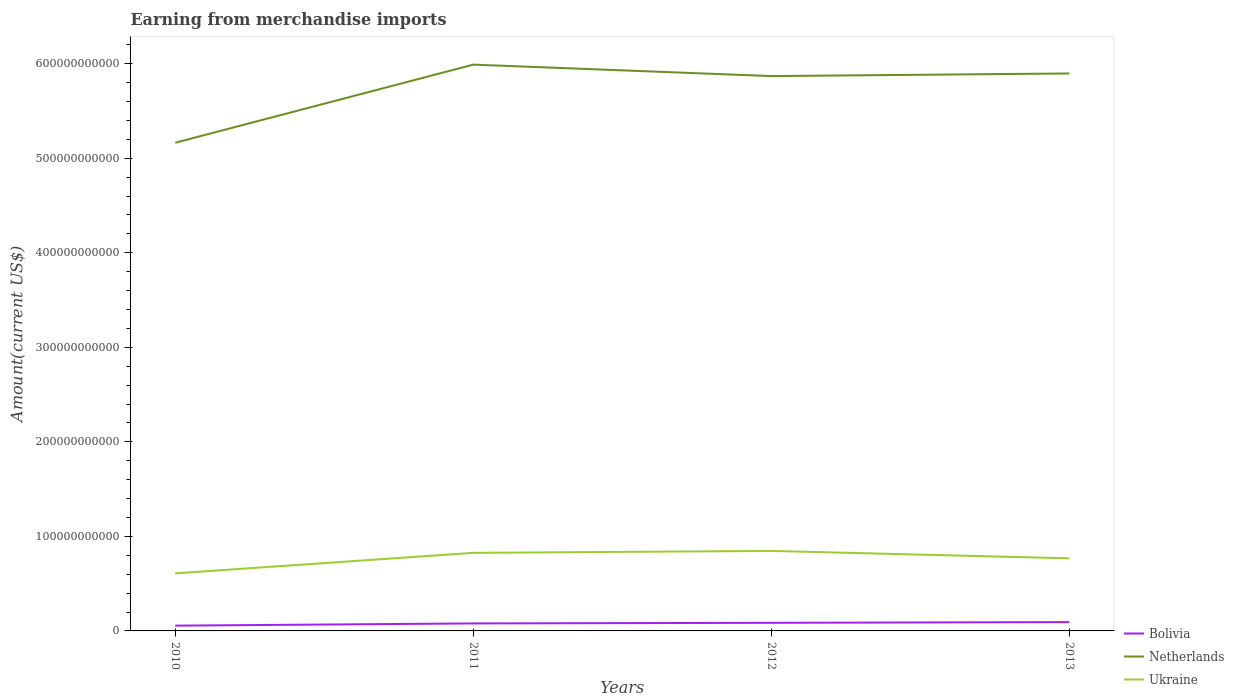Across all years, what is the maximum amount earned from merchandise imports in Ukraine?
Your response must be concise. 6.09e+1. In which year was the amount earned from merchandise imports in Ukraine maximum?
Provide a short and direct response. 2010. What is the total amount earned from merchandise imports in Bolivia in the graph?
Give a very brief answer. -2.34e+09. What is the difference between the highest and the second highest amount earned from merchandise imports in Bolivia?
Offer a very short reply. 3.75e+09. What is the difference between the highest and the lowest amount earned from merchandise imports in Bolivia?
Offer a very short reply. 3. How many lines are there?
Your response must be concise. 3. How many years are there in the graph?
Your answer should be compact. 4. What is the difference between two consecutive major ticks on the Y-axis?
Your answer should be compact. 1.00e+11. How are the legend labels stacked?
Make the answer very short. Vertical. What is the title of the graph?
Make the answer very short. Earning from merchandise imports. What is the label or title of the X-axis?
Provide a succinct answer. Years. What is the label or title of the Y-axis?
Offer a terse response. Amount(current US$). What is the Amount(current US$) in Bolivia in 2010?
Give a very brief answer. 5.59e+09. What is the Amount(current US$) in Netherlands in 2010?
Ensure brevity in your answer.  5.16e+11. What is the Amount(current US$) in Ukraine in 2010?
Your answer should be compact. 6.09e+1. What is the Amount(current US$) of Bolivia in 2011?
Keep it short and to the point. 7.93e+09. What is the Amount(current US$) of Netherlands in 2011?
Keep it short and to the point. 5.99e+11. What is the Amount(current US$) in Ukraine in 2011?
Your answer should be very brief. 8.26e+1. What is the Amount(current US$) of Bolivia in 2012?
Keep it short and to the point. 8.58e+09. What is the Amount(current US$) in Netherlands in 2012?
Ensure brevity in your answer.  5.87e+11. What is the Amount(current US$) in Ukraine in 2012?
Provide a succinct answer. 8.46e+1. What is the Amount(current US$) of Bolivia in 2013?
Make the answer very short. 9.34e+09. What is the Amount(current US$) in Netherlands in 2013?
Your answer should be very brief. 5.90e+11. What is the Amount(current US$) of Ukraine in 2013?
Make the answer very short. 7.68e+1. Across all years, what is the maximum Amount(current US$) of Bolivia?
Give a very brief answer. 9.34e+09. Across all years, what is the maximum Amount(current US$) of Netherlands?
Offer a very short reply. 5.99e+11. Across all years, what is the maximum Amount(current US$) of Ukraine?
Keep it short and to the point. 8.46e+1. Across all years, what is the minimum Amount(current US$) in Bolivia?
Offer a very short reply. 5.59e+09. Across all years, what is the minimum Amount(current US$) of Netherlands?
Offer a terse response. 5.16e+11. Across all years, what is the minimum Amount(current US$) of Ukraine?
Ensure brevity in your answer.  6.09e+1. What is the total Amount(current US$) of Bolivia in the graph?
Offer a very short reply. 3.14e+1. What is the total Amount(current US$) in Netherlands in the graph?
Your response must be concise. 2.29e+12. What is the total Amount(current US$) in Ukraine in the graph?
Ensure brevity in your answer.  3.05e+11. What is the difference between the Amount(current US$) in Bolivia in 2010 and that in 2011?
Provide a succinct answer. -2.34e+09. What is the difference between the Amount(current US$) of Netherlands in 2010 and that in 2011?
Provide a succinct answer. -8.26e+1. What is the difference between the Amount(current US$) of Ukraine in 2010 and that in 2011?
Provide a succinct answer. -2.17e+1. What is the difference between the Amount(current US$) of Bolivia in 2010 and that in 2012?
Offer a very short reply. -2.99e+09. What is the difference between the Amount(current US$) of Netherlands in 2010 and that in 2012?
Your answer should be very brief. -7.05e+1. What is the difference between the Amount(current US$) of Ukraine in 2010 and that in 2012?
Offer a very short reply. -2.37e+1. What is the difference between the Amount(current US$) in Bolivia in 2010 and that in 2013?
Your answer should be very brief. -3.75e+09. What is the difference between the Amount(current US$) of Netherlands in 2010 and that in 2013?
Make the answer very short. -7.33e+1. What is the difference between the Amount(current US$) of Ukraine in 2010 and that in 2013?
Offer a very short reply. -1.59e+1. What is the difference between the Amount(current US$) in Bolivia in 2011 and that in 2012?
Ensure brevity in your answer.  -6.51e+08. What is the difference between the Amount(current US$) of Netherlands in 2011 and that in 2012?
Your answer should be very brief. 1.21e+1. What is the difference between the Amount(current US$) in Ukraine in 2011 and that in 2012?
Offer a terse response. -2.04e+09. What is the difference between the Amount(current US$) of Bolivia in 2011 and that in 2013?
Your answer should be compact. -1.41e+09. What is the difference between the Amount(current US$) of Netherlands in 2011 and that in 2013?
Ensure brevity in your answer.  9.34e+09. What is the difference between the Amount(current US$) in Ukraine in 2011 and that in 2013?
Offer a terse response. 5.81e+09. What is the difference between the Amount(current US$) of Bolivia in 2012 and that in 2013?
Your answer should be very brief. -7.59e+08. What is the difference between the Amount(current US$) of Netherlands in 2012 and that in 2013?
Your answer should be very brief. -2.77e+09. What is the difference between the Amount(current US$) of Ukraine in 2012 and that in 2013?
Your answer should be very brief. 7.85e+09. What is the difference between the Amount(current US$) of Bolivia in 2010 and the Amount(current US$) of Netherlands in 2011?
Your answer should be compact. -5.93e+11. What is the difference between the Amount(current US$) of Bolivia in 2010 and the Amount(current US$) of Ukraine in 2011?
Give a very brief answer. -7.70e+1. What is the difference between the Amount(current US$) of Netherlands in 2010 and the Amount(current US$) of Ukraine in 2011?
Ensure brevity in your answer.  4.34e+11. What is the difference between the Amount(current US$) in Bolivia in 2010 and the Amount(current US$) in Netherlands in 2012?
Offer a very short reply. -5.81e+11. What is the difference between the Amount(current US$) in Bolivia in 2010 and the Amount(current US$) in Ukraine in 2012?
Your answer should be very brief. -7.90e+1. What is the difference between the Amount(current US$) in Netherlands in 2010 and the Amount(current US$) in Ukraine in 2012?
Provide a short and direct response. 4.32e+11. What is the difference between the Amount(current US$) of Bolivia in 2010 and the Amount(current US$) of Netherlands in 2013?
Make the answer very short. -5.84e+11. What is the difference between the Amount(current US$) of Bolivia in 2010 and the Amount(current US$) of Ukraine in 2013?
Offer a very short reply. -7.12e+1. What is the difference between the Amount(current US$) of Netherlands in 2010 and the Amount(current US$) of Ukraine in 2013?
Make the answer very short. 4.40e+11. What is the difference between the Amount(current US$) of Bolivia in 2011 and the Amount(current US$) of Netherlands in 2012?
Keep it short and to the point. -5.79e+11. What is the difference between the Amount(current US$) in Bolivia in 2011 and the Amount(current US$) in Ukraine in 2012?
Your answer should be compact. -7.67e+1. What is the difference between the Amount(current US$) of Netherlands in 2011 and the Amount(current US$) of Ukraine in 2012?
Offer a very short reply. 5.14e+11. What is the difference between the Amount(current US$) in Bolivia in 2011 and the Amount(current US$) in Netherlands in 2013?
Offer a terse response. -5.82e+11. What is the difference between the Amount(current US$) of Bolivia in 2011 and the Amount(current US$) of Ukraine in 2013?
Give a very brief answer. -6.89e+1. What is the difference between the Amount(current US$) of Netherlands in 2011 and the Amount(current US$) of Ukraine in 2013?
Offer a terse response. 5.22e+11. What is the difference between the Amount(current US$) of Bolivia in 2012 and the Amount(current US$) of Netherlands in 2013?
Give a very brief answer. -5.81e+11. What is the difference between the Amount(current US$) of Bolivia in 2012 and the Amount(current US$) of Ukraine in 2013?
Offer a very short reply. -6.82e+1. What is the difference between the Amount(current US$) in Netherlands in 2012 and the Amount(current US$) in Ukraine in 2013?
Keep it short and to the point. 5.10e+11. What is the average Amount(current US$) in Bolivia per year?
Ensure brevity in your answer.  7.86e+09. What is the average Amount(current US$) of Netherlands per year?
Ensure brevity in your answer.  5.73e+11. What is the average Amount(current US$) in Ukraine per year?
Ensure brevity in your answer.  7.62e+1. In the year 2010, what is the difference between the Amount(current US$) in Bolivia and Amount(current US$) in Netherlands?
Your answer should be very brief. -5.11e+11. In the year 2010, what is the difference between the Amount(current US$) in Bolivia and Amount(current US$) in Ukraine?
Keep it short and to the point. -5.53e+1. In the year 2010, what is the difference between the Amount(current US$) of Netherlands and Amount(current US$) of Ukraine?
Ensure brevity in your answer.  4.55e+11. In the year 2011, what is the difference between the Amount(current US$) of Bolivia and Amount(current US$) of Netherlands?
Keep it short and to the point. -5.91e+11. In the year 2011, what is the difference between the Amount(current US$) of Bolivia and Amount(current US$) of Ukraine?
Offer a terse response. -7.47e+1. In the year 2011, what is the difference between the Amount(current US$) of Netherlands and Amount(current US$) of Ukraine?
Give a very brief answer. 5.16e+11. In the year 2012, what is the difference between the Amount(current US$) of Bolivia and Amount(current US$) of Netherlands?
Ensure brevity in your answer.  -5.78e+11. In the year 2012, what is the difference between the Amount(current US$) in Bolivia and Amount(current US$) in Ukraine?
Your answer should be compact. -7.61e+1. In the year 2012, what is the difference between the Amount(current US$) of Netherlands and Amount(current US$) of Ukraine?
Offer a terse response. 5.02e+11. In the year 2013, what is the difference between the Amount(current US$) in Bolivia and Amount(current US$) in Netherlands?
Your answer should be very brief. -5.80e+11. In the year 2013, what is the difference between the Amount(current US$) of Bolivia and Amount(current US$) of Ukraine?
Provide a succinct answer. -6.74e+1. In the year 2013, what is the difference between the Amount(current US$) in Netherlands and Amount(current US$) in Ukraine?
Keep it short and to the point. 5.13e+11. What is the ratio of the Amount(current US$) in Bolivia in 2010 to that in 2011?
Ensure brevity in your answer.  0.71. What is the ratio of the Amount(current US$) of Netherlands in 2010 to that in 2011?
Give a very brief answer. 0.86. What is the ratio of the Amount(current US$) of Ukraine in 2010 to that in 2011?
Offer a very short reply. 0.74. What is the ratio of the Amount(current US$) of Bolivia in 2010 to that in 2012?
Your answer should be compact. 0.65. What is the ratio of the Amount(current US$) of Netherlands in 2010 to that in 2012?
Your response must be concise. 0.88. What is the ratio of the Amount(current US$) of Ukraine in 2010 to that in 2012?
Provide a succinct answer. 0.72. What is the ratio of the Amount(current US$) of Bolivia in 2010 to that in 2013?
Your answer should be very brief. 0.6. What is the ratio of the Amount(current US$) of Netherlands in 2010 to that in 2013?
Give a very brief answer. 0.88. What is the ratio of the Amount(current US$) in Ukraine in 2010 to that in 2013?
Provide a short and direct response. 0.79. What is the ratio of the Amount(current US$) of Bolivia in 2011 to that in 2012?
Give a very brief answer. 0.92. What is the ratio of the Amount(current US$) in Netherlands in 2011 to that in 2012?
Offer a very short reply. 1.02. What is the ratio of the Amount(current US$) in Ukraine in 2011 to that in 2012?
Your answer should be compact. 0.98. What is the ratio of the Amount(current US$) in Bolivia in 2011 to that in 2013?
Your response must be concise. 0.85. What is the ratio of the Amount(current US$) in Netherlands in 2011 to that in 2013?
Ensure brevity in your answer.  1.02. What is the ratio of the Amount(current US$) of Ukraine in 2011 to that in 2013?
Offer a terse response. 1.08. What is the ratio of the Amount(current US$) in Bolivia in 2012 to that in 2013?
Your response must be concise. 0.92. What is the ratio of the Amount(current US$) of Netherlands in 2012 to that in 2013?
Offer a very short reply. 1. What is the ratio of the Amount(current US$) of Ukraine in 2012 to that in 2013?
Provide a short and direct response. 1.1. What is the difference between the highest and the second highest Amount(current US$) of Bolivia?
Ensure brevity in your answer.  7.59e+08. What is the difference between the highest and the second highest Amount(current US$) in Netherlands?
Your answer should be very brief. 9.34e+09. What is the difference between the highest and the second highest Amount(current US$) in Ukraine?
Make the answer very short. 2.04e+09. What is the difference between the highest and the lowest Amount(current US$) in Bolivia?
Your response must be concise. 3.75e+09. What is the difference between the highest and the lowest Amount(current US$) of Netherlands?
Your answer should be very brief. 8.26e+1. What is the difference between the highest and the lowest Amount(current US$) of Ukraine?
Your answer should be very brief. 2.37e+1. 